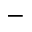Convert formula to latex. <formula><loc_0><loc_0><loc_500><loc_500>-</formula> 